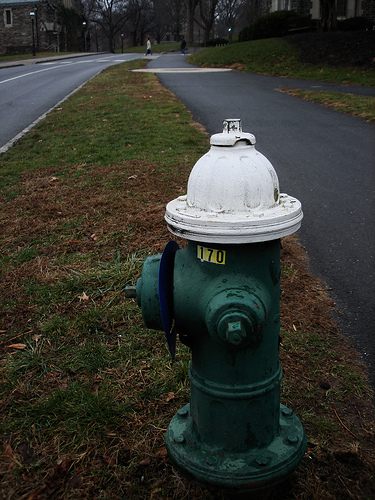Please provide a short description for this region: [0.47, 0.81, 0.5, 0.84]. This region, identified by coordinates [0.47, 0.81, 0.5, 0.84], contains a green bolt on the fire hydrant, a small but significant detail in municipal infrastructure. 